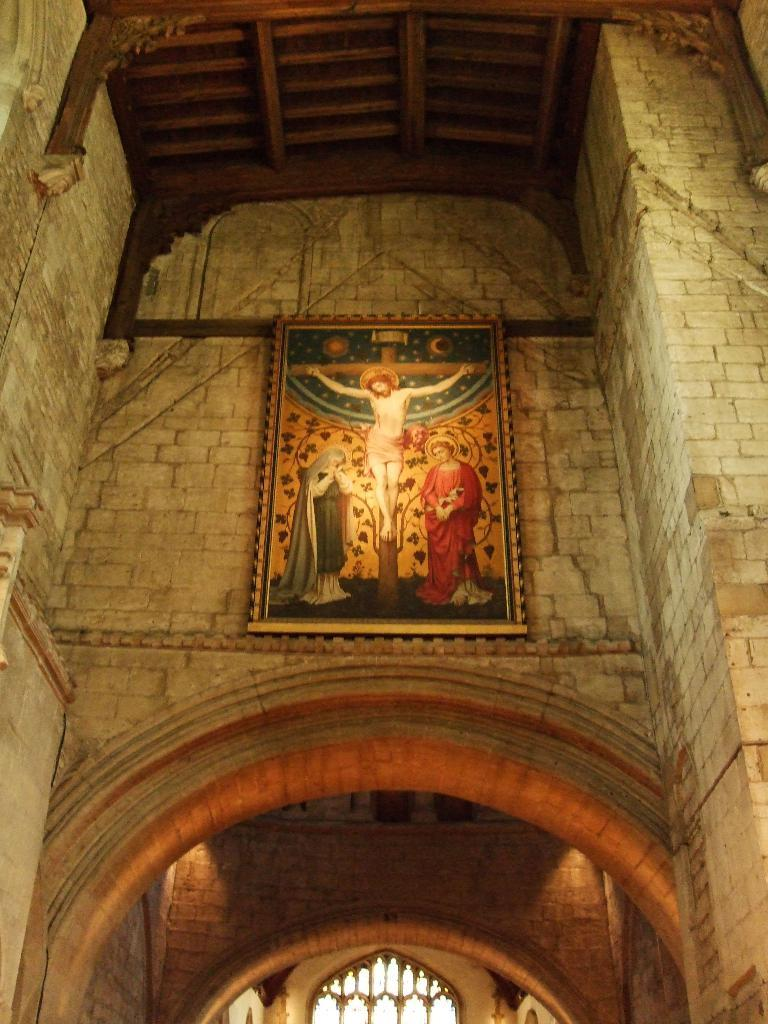What type of structure is shown in the image? There is a building in the image. Where does the image take place within the building? The image shows an inside view of the building. What can be seen on the walls in the image? There is a wall visible in the image, and a photo frame is attached to it. What is displayed in the photo frame? The photo frame contains images of people. What type of chalk is used to draw on the wall in the image? There is no chalk or drawing on the wall in the image; it only shows a photo frame with images of people. Can you see a badge on any of the people in the photo frame? The images in the photo frame do not show any badges on the people. 